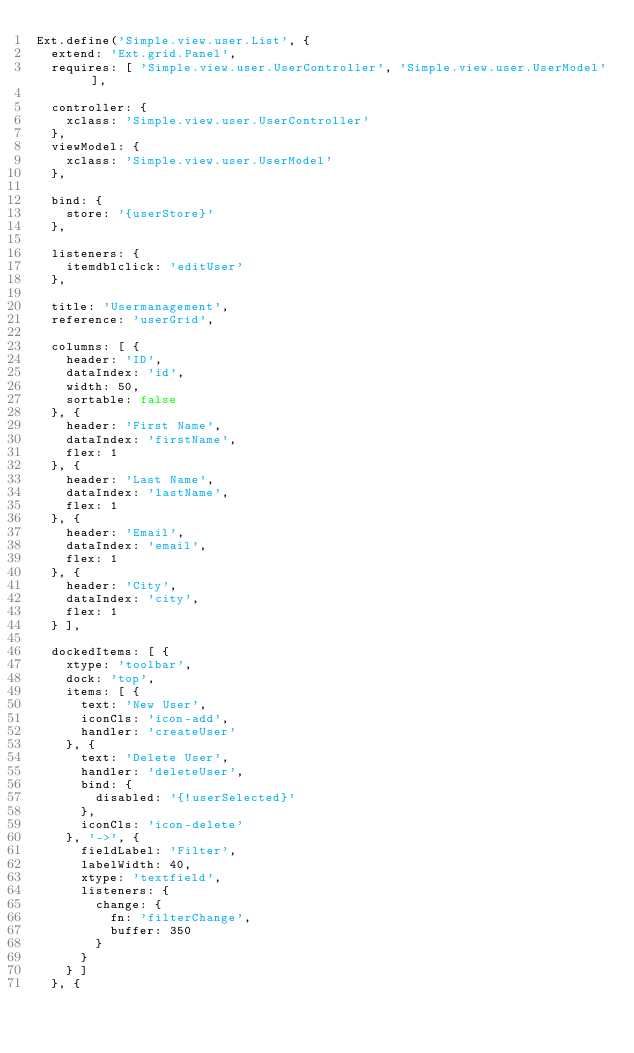<code> <loc_0><loc_0><loc_500><loc_500><_JavaScript_>Ext.define('Simple.view.user.List', {
	extend: 'Ext.grid.Panel',
	requires: [ 'Simple.view.user.UserController', 'Simple.view.user.UserModel' ],

	controller: {
		xclass: 'Simple.view.user.UserController'
	},
	viewModel: {
		xclass: 'Simple.view.user.UserModel'
	},

	bind: {
		store: '{userStore}'
	},

	listeners: {
		itemdblclick: 'editUser'
	},

	title: 'Usermanagement',
	reference: 'userGrid',

	columns: [ {
		header: 'ID',
		dataIndex: 'id',
		width: 50,
		sortable: false
	}, {
		header: 'First Name',
		dataIndex: 'firstName',
		flex: 1
	}, {
		header: 'Last Name',
		dataIndex: 'lastName',
		flex: 1
	}, {
		header: 'Email',
		dataIndex: 'email',
		flex: 1
	}, {
		header: 'City',
		dataIndex: 'city',
		flex: 1
	} ],

	dockedItems: [ {
		xtype: 'toolbar',
		dock: 'top',
		items: [ {
			text: 'New User',
			iconCls: 'icon-add',
			handler: 'createUser'
		}, {
			text: 'Delete User',
			handler: 'deleteUser',
			bind: {
				disabled: '{!userSelected}'
			},
			iconCls: 'icon-delete'
		}, '->', {
			fieldLabel: 'Filter',
			labelWidth: 40,
			xtype: 'textfield',
			listeners: {
				change: {
					fn: 'filterChange',
					buffer: 350
				}
			}
		} ]
	}, {</code> 